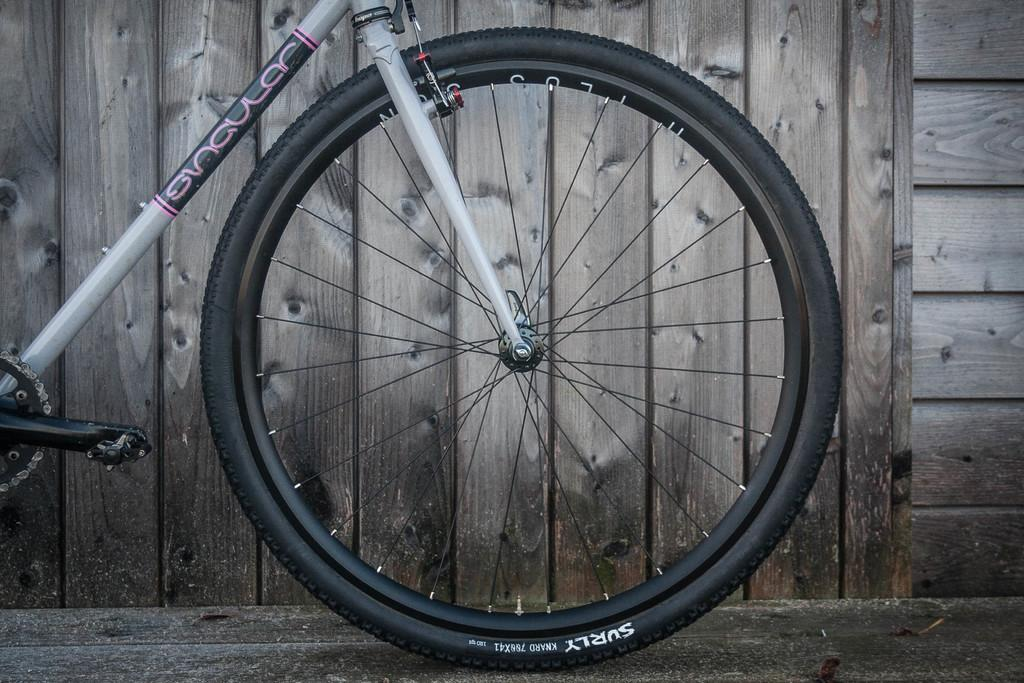What is the main object in the image? There is a bicycle in the image. What colors can be seen on the bicycle? The bicycle is white and black in color. Where is the bicycle located in the image? The bicycle is on the ground. What can be seen in the background of the image? There is a wooden wall in the background of the image. Who is the expert on the bicycle in the image? There is no expert present in the image; it simply shows a bicycle on the ground. Can you tell me how many turkeys are visible in the image? There are no turkeys present in the image; it features a bicycle and a wooden wall in the background. 